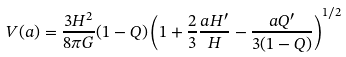Convert formula to latex. <formula><loc_0><loc_0><loc_500><loc_500>V ( a ) = \frac { 3 H ^ { 2 } } { 8 \pi G } ( 1 - Q ) \left ( 1 + \frac { 2 } { 3 } \frac { a H ^ { \prime } } { H } - \frac { a Q ^ { \prime } } { 3 ( 1 - Q ) } \right ) ^ { 1 / 2 }</formula> 